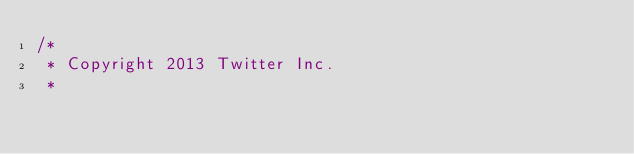Convert code to text. <code><loc_0><loc_0><loc_500><loc_500><_Scala_>/*
 * Copyright 2013 Twitter Inc.
 *</code> 